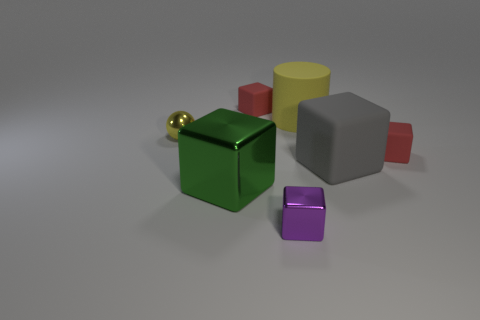Are there any green things that have the same size as the cylinder?
Your answer should be very brief. Yes. Is there a yellow rubber thing on the right side of the red rubber thing that is in front of the yellow rubber cylinder?
Your answer should be compact. No. What number of cubes are tiny matte objects or tiny yellow metallic things?
Make the answer very short. 2. Are there any cyan matte things that have the same shape as the tiny yellow metal object?
Provide a short and direct response. No. What shape is the big shiny thing?
Give a very brief answer. Cube. What number of objects are either gray blocks or tiny shiny cubes?
Keep it short and to the point. 2. Is the size of the red object that is in front of the large yellow rubber object the same as the yellow object that is left of the big yellow object?
Offer a very short reply. Yes. What number of other things are the same material as the ball?
Keep it short and to the point. 2. Is the number of tiny purple metallic blocks that are in front of the yellow cylinder greater than the number of tiny purple metallic objects that are right of the shiny sphere?
Your answer should be very brief. No. There is a big block that is behind the large green object; what material is it?
Your response must be concise. Rubber. 